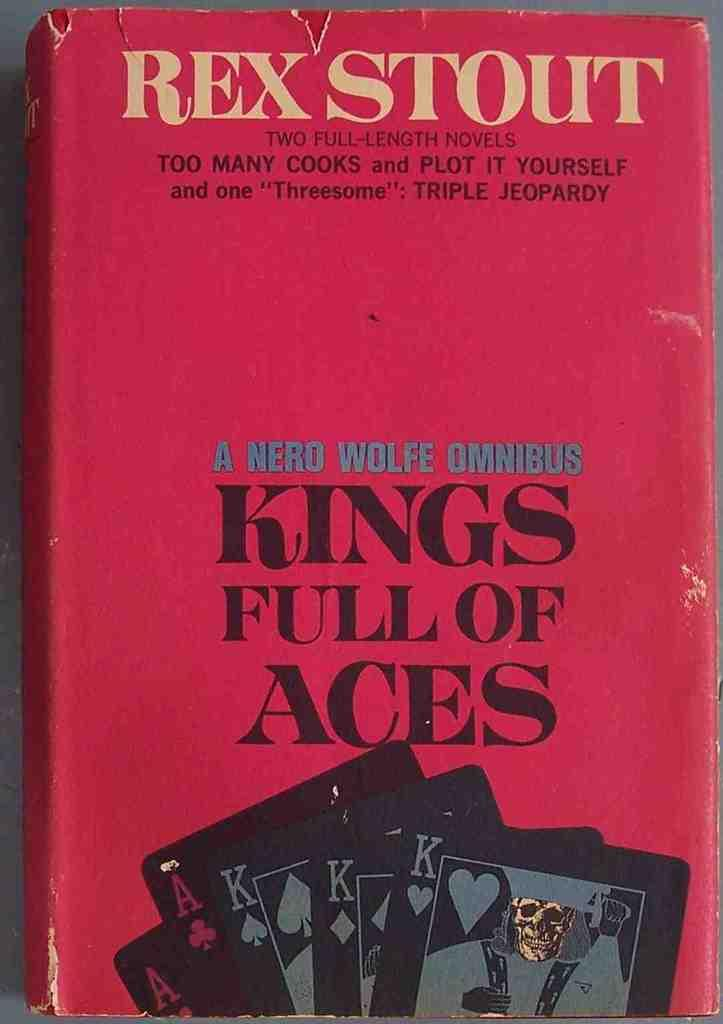<image>
Write a terse but informative summary of the picture. The book Kings Full of Aces sits on a table. 